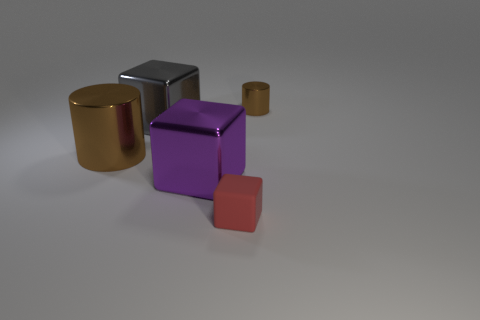Do the brown cylinder to the right of the small red matte object and the large gray block have the same material?
Provide a succinct answer. Yes. There is a cylinder that is behind the brown metal cylinder that is on the left side of the red object; how big is it?
Keep it short and to the point. Small. What is the color of the shiny object that is in front of the tiny shiny thing and to the right of the large gray metallic block?
Provide a succinct answer. Purple. How many other objects are the same material as the purple object?
Ensure brevity in your answer.  3. There is a tiny object that is on the right side of the red rubber block; does it have the same color as the object on the left side of the big gray cube?
Your response must be concise. Yes. The tiny thing that is behind the rubber block that is in front of the purple block is what shape?
Provide a succinct answer. Cylinder. What number of other things are the same color as the tiny matte thing?
Keep it short and to the point. 0. Does the brown cylinder that is to the right of the tiny matte block have the same material as the large cube to the left of the purple shiny object?
Your answer should be very brief. Yes. What is the size of the shiny block that is to the right of the gray block?
Provide a short and direct response. Large. There is another brown object that is the same shape as the big brown metal object; what is its material?
Your answer should be very brief. Metal. 